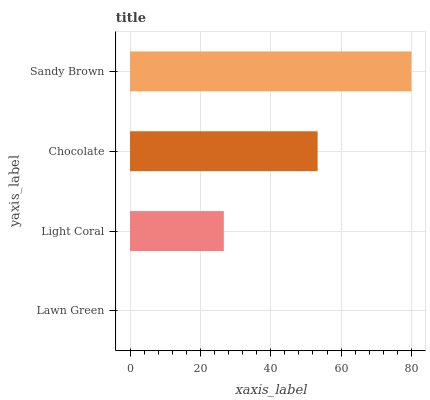Is Lawn Green the minimum?
Answer yes or no. Yes. Is Sandy Brown the maximum?
Answer yes or no. Yes. Is Light Coral the minimum?
Answer yes or no. No. Is Light Coral the maximum?
Answer yes or no. No. Is Light Coral greater than Lawn Green?
Answer yes or no. Yes. Is Lawn Green less than Light Coral?
Answer yes or no. Yes. Is Lawn Green greater than Light Coral?
Answer yes or no. No. Is Light Coral less than Lawn Green?
Answer yes or no. No. Is Chocolate the high median?
Answer yes or no. Yes. Is Light Coral the low median?
Answer yes or no. Yes. Is Sandy Brown the high median?
Answer yes or no. No. Is Sandy Brown the low median?
Answer yes or no. No. 